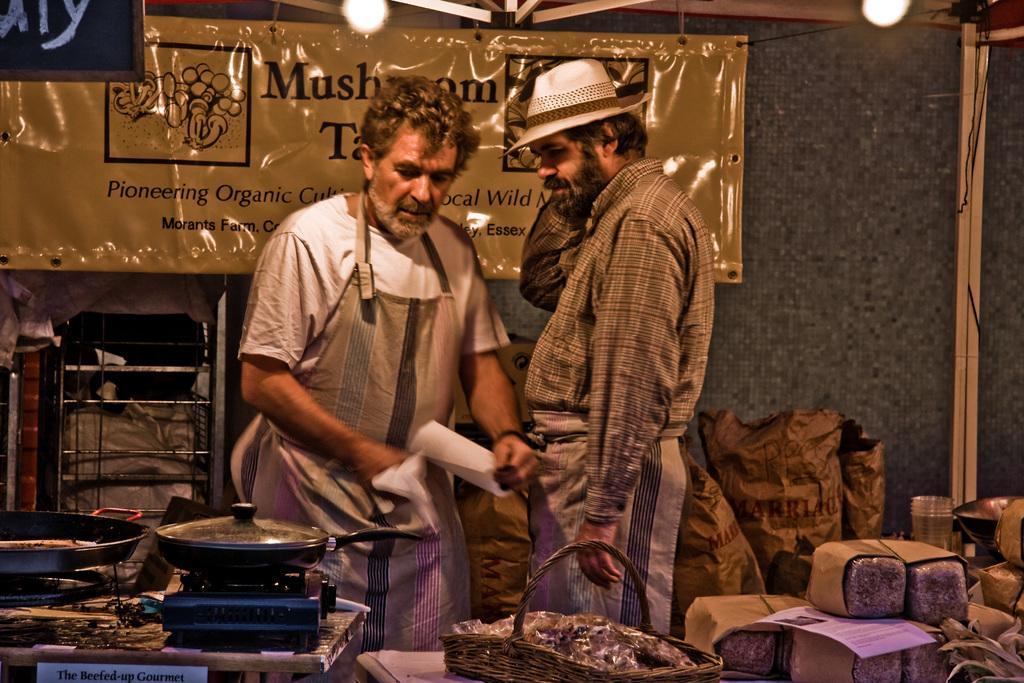Describe this image in one or two sentences. In this image we can see two persons standing and we can also see a gas stove, non stick pans, basket, food items and lights. Behind them we can see a board with some text. 